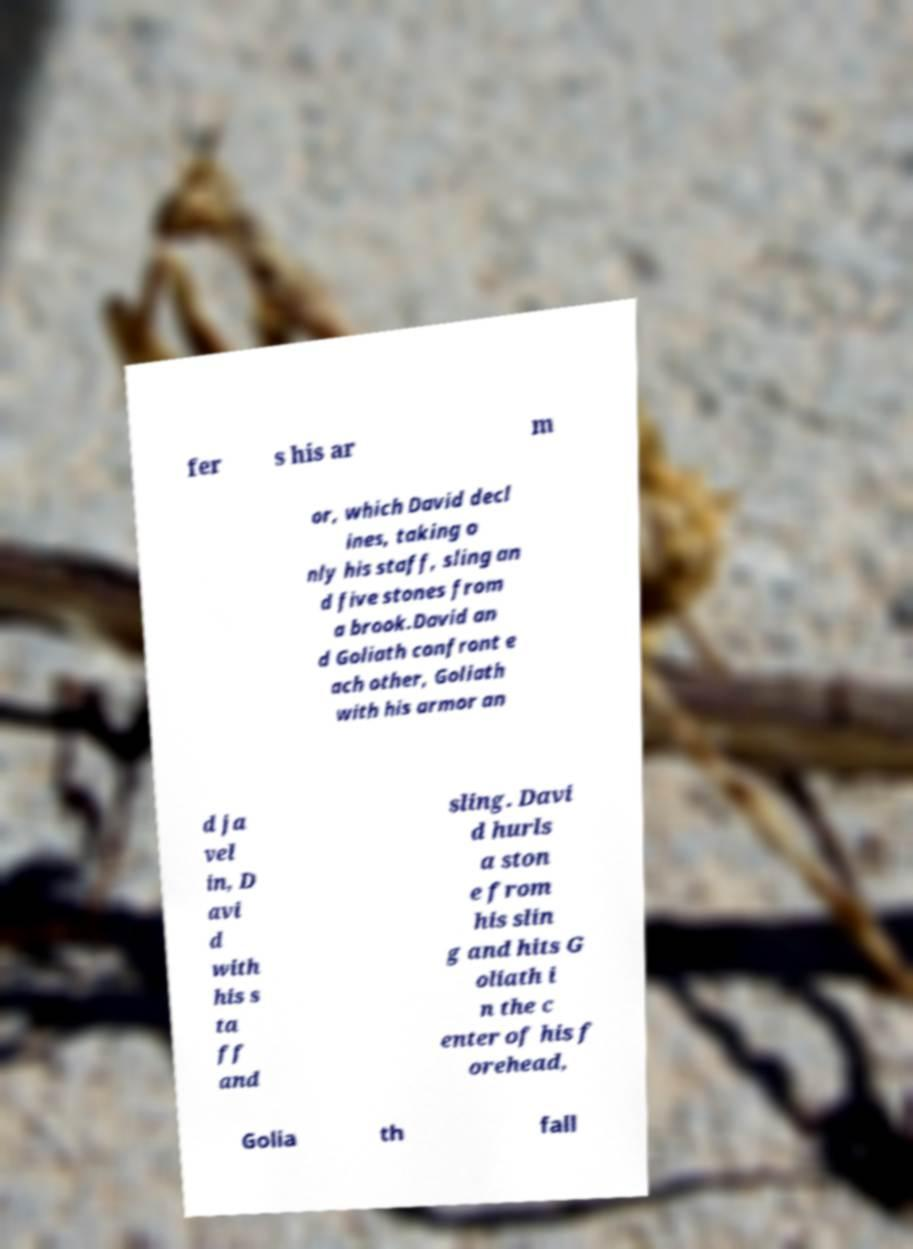Please read and relay the text visible in this image. What does it say? fer s his ar m or, which David decl ines, taking o nly his staff, sling an d five stones from a brook.David an d Goliath confront e ach other, Goliath with his armor an d ja vel in, D avi d with his s ta ff and sling. Davi d hurls a ston e from his slin g and hits G oliath i n the c enter of his f orehead, Golia th fall 